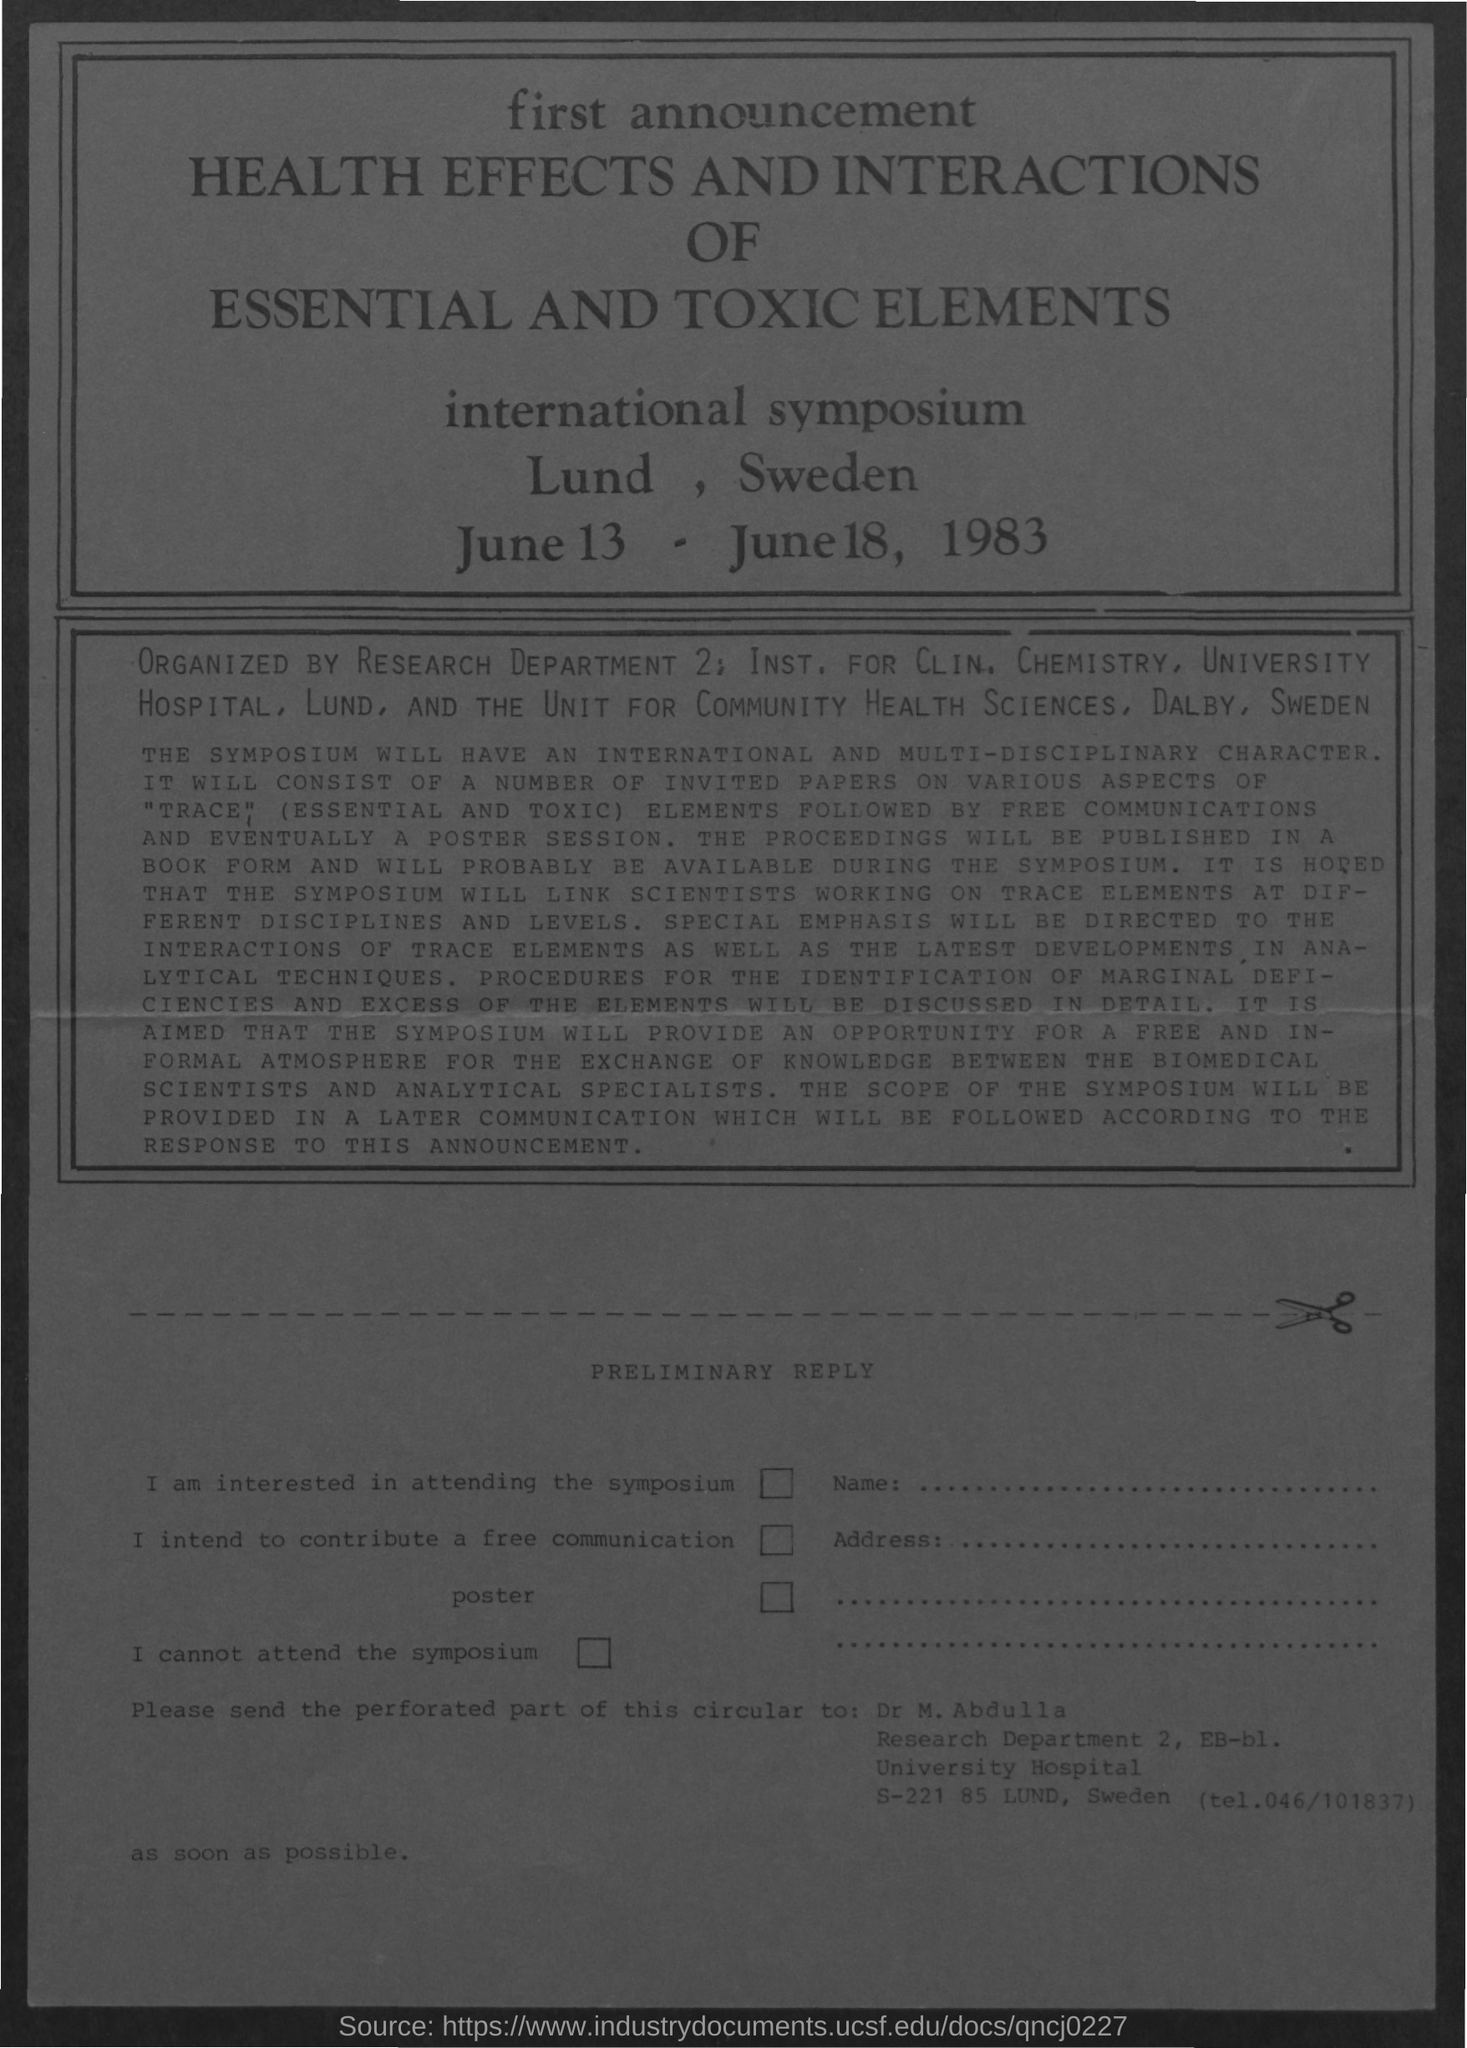Mention a couple of crucial points in this snapshot. The date mentioned is June 13 to June 18, 1983. This document serves as a comprehensive overview of the health effects and interactions of both essential and toxic elements. 